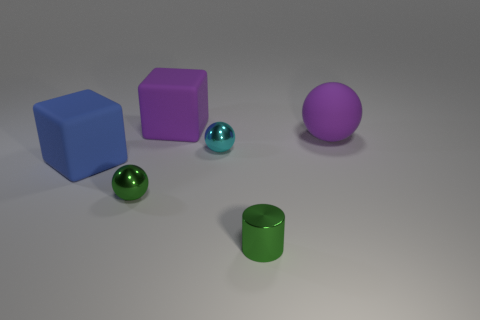Are there any other things that are the same size as the blue rubber thing?
Your answer should be very brief. Yes. How many cubes have the same color as the big rubber sphere?
Your answer should be compact. 1. What is the material of the big object that is the same color as the rubber sphere?
Offer a terse response. Rubber. Is the tiny cyan sphere made of the same material as the tiny green sphere?
Offer a terse response. Yes. Are there any shiny spheres behind the blue rubber cube?
Ensure brevity in your answer.  Yes. The tiny sphere in front of the cyan shiny ball behind the big blue object is made of what material?
Provide a succinct answer. Metal. What size is the other matte thing that is the same shape as the small cyan thing?
Your answer should be compact. Large. The sphere that is both to the left of the shiny cylinder and behind the small green metal sphere is what color?
Your answer should be very brief. Cyan. Do the purple matte thing that is left of the cylinder and the small green metallic cylinder have the same size?
Your answer should be compact. No. Is the cylinder made of the same material as the large block behind the large blue object?
Provide a short and direct response. No. 